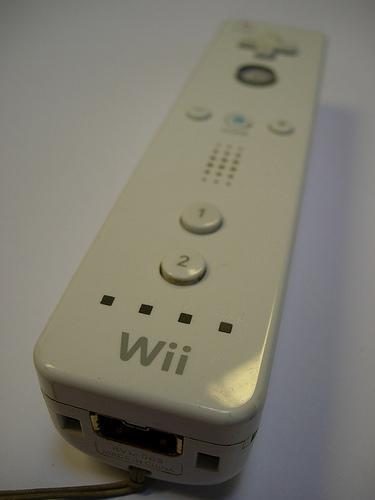How many controllers are there?
Give a very brief answer. 1. 